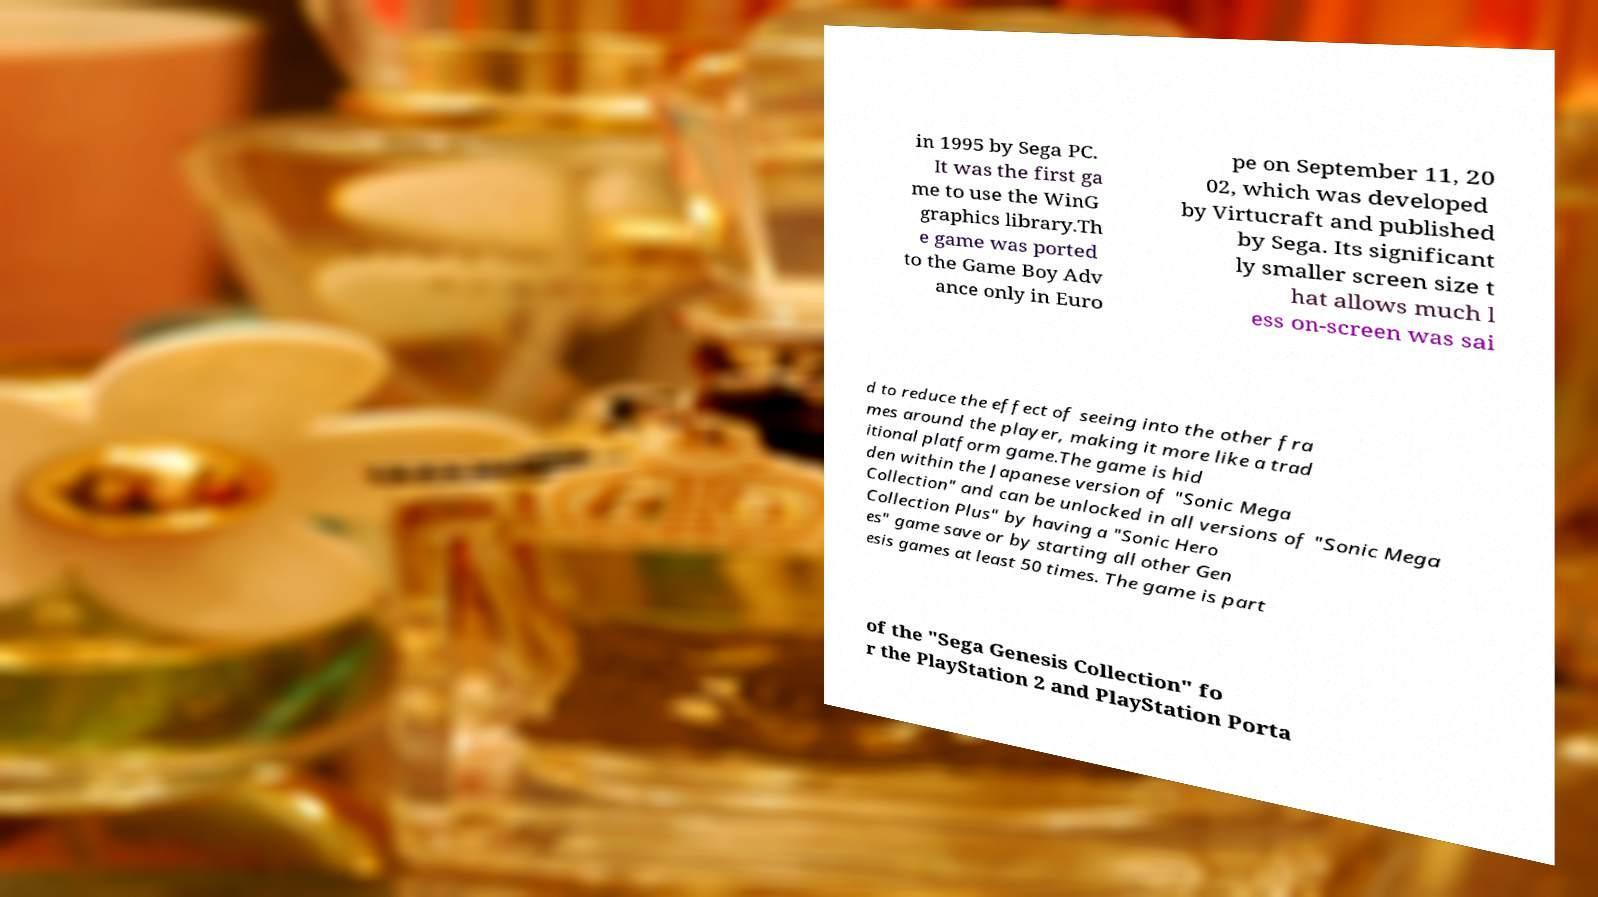Can you read and provide the text displayed in the image?This photo seems to have some interesting text. Can you extract and type it out for me? in 1995 by Sega PC. It was the first ga me to use the WinG graphics library.Th e game was ported to the Game Boy Adv ance only in Euro pe on September 11, 20 02, which was developed by Virtucraft and published by Sega. Its significant ly smaller screen size t hat allows much l ess on-screen was sai d to reduce the effect of seeing into the other fra mes around the player, making it more like a trad itional platform game.The game is hid den within the Japanese version of "Sonic Mega Collection" and can be unlocked in all versions of "Sonic Mega Collection Plus" by having a "Sonic Hero es" game save or by starting all other Gen esis games at least 50 times. The game is part of the "Sega Genesis Collection" fo r the PlayStation 2 and PlayStation Porta 